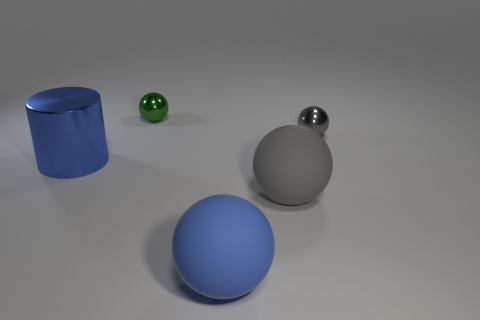What material is the blue thing left of the small ball that is behind the shiny sphere that is in front of the green metal sphere?
Keep it short and to the point. Metal. Are there any blue metallic cubes of the same size as the cylinder?
Your response must be concise. No. What size is the gray sphere that is the same material as the small green thing?
Provide a short and direct response. Small. What is the shape of the big gray matte thing?
Make the answer very short. Sphere. Is the material of the large gray thing the same as the gray ball behind the blue cylinder?
Your answer should be compact. No. What number of objects are either gray objects or shiny cylinders?
Your answer should be very brief. 3. Are there any large red objects?
Give a very brief answer. No. The big object that is to the left of the big blue matte object that is in front of the green ball is what shape?
Make the answer very short. Cylinder. What number of things are shiny balls that are right of the green shiny object or big gray spheres that are in front of the gray metal ball?
Make the answer very short. 2. What is the material of the other thing that is the same size as the green metal thing?
Give a very brief answer. Metal. 